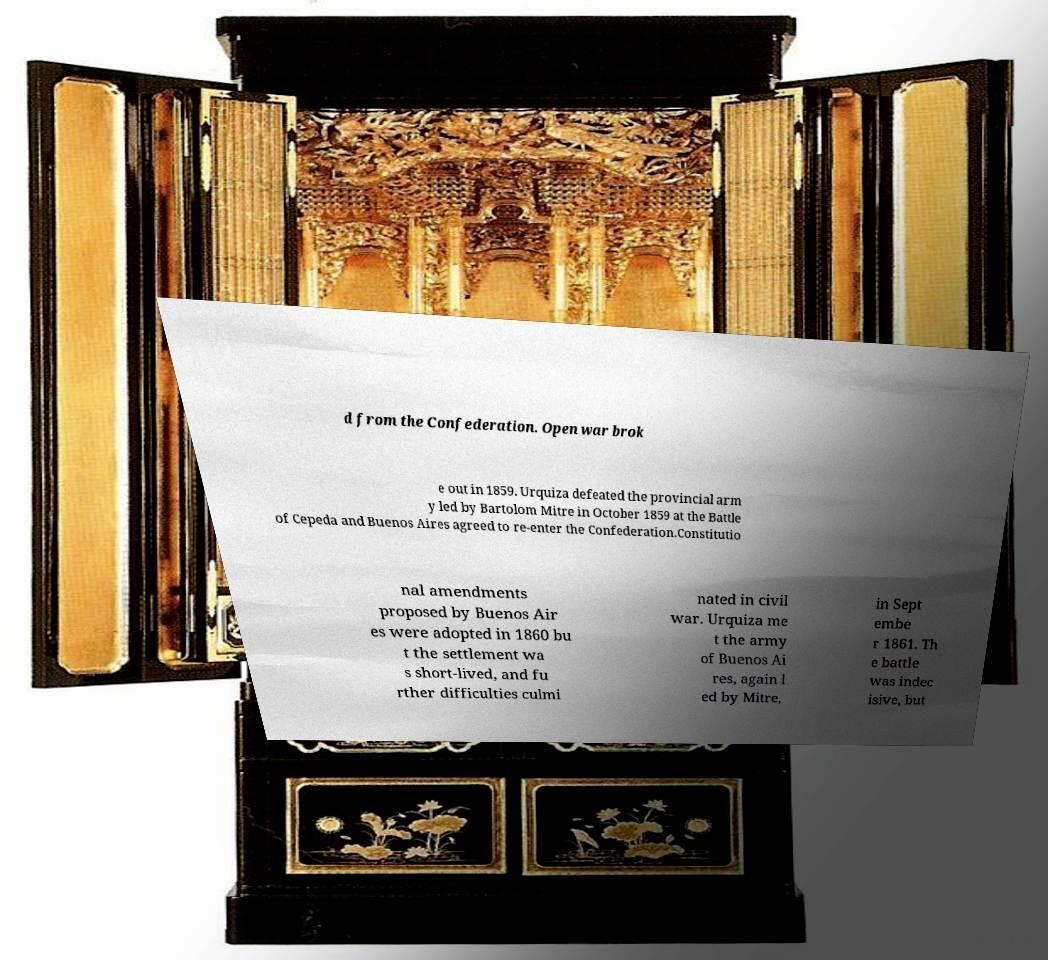Could you extract and type out the text from this image? d from the Confederation. Open war brok e out in 1859. Urquiza defeated the provincial arm y led by Bartolom Mitre in October 1859 at the Battle of Cepeda and Buenos Aires agreed to re-enter the Confederation.Constitutio nal amendments proposed by Buenos Air es were adopted in 1860 bu t the settlement wa s short-lived, and fu rther difficulties culmi nated in civil war. Urquiza me t the army of Buenos Ai res, again l ed by Mitre, in Sept embe r 1861. Th e battle was indec isive, but 